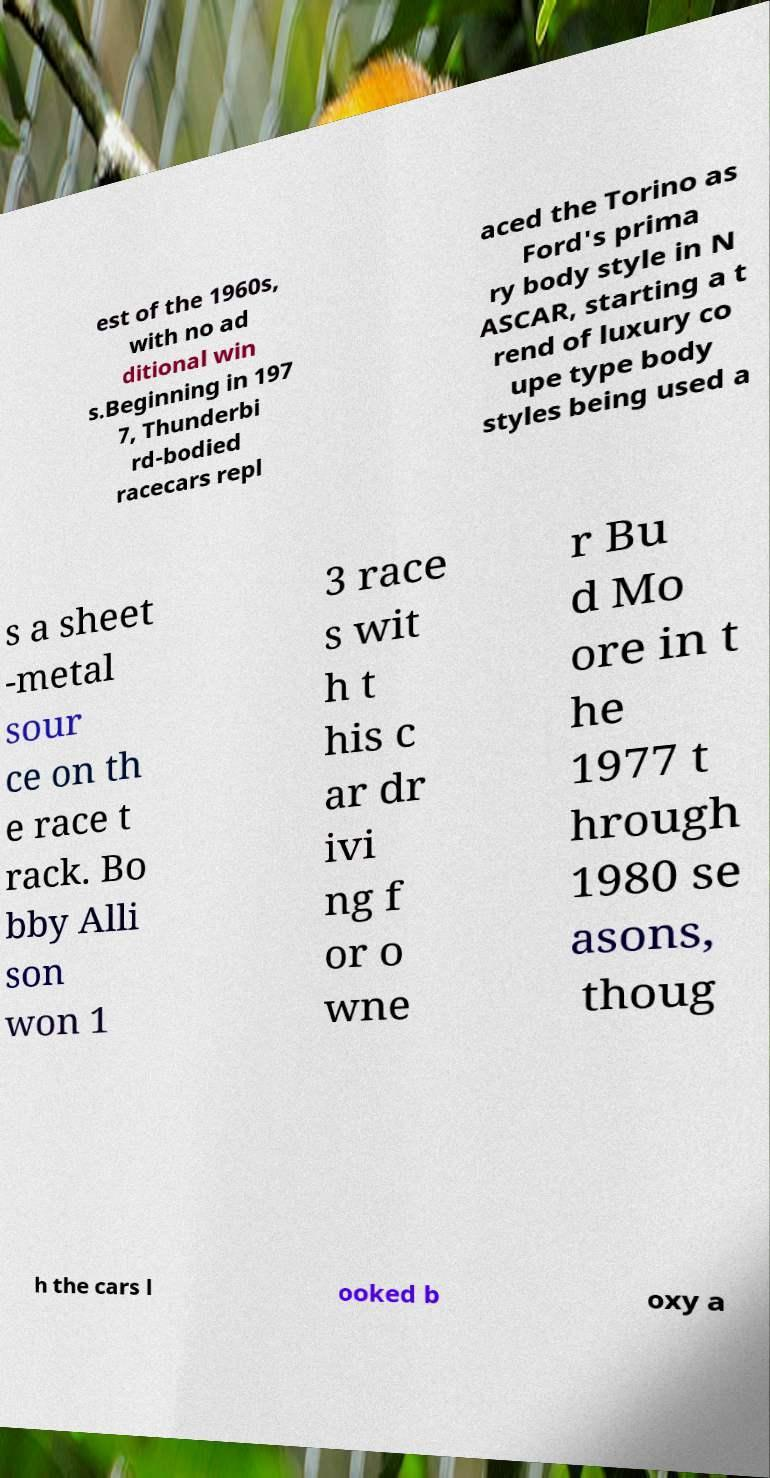Please read and relay the text visible in this image. What does it say? est of the 1960s, with no ad ditional win s.Beginning in 197 7, Thunderbi rd-bodied racecars repl aced the Torino as Ford's prima ry body style in N ASCAR, starting a t rend of luxury co upe type body styles being used a s a sheet -metal sour ce on th e race t rack. Bo bby Alli son won 1 3 race s wit h t his c ar dr ivi ng f or o wne r Bu d Mo ore in t he 1977 t hrough 1980 se asons, thoug h the cars l ooked b oxy a 